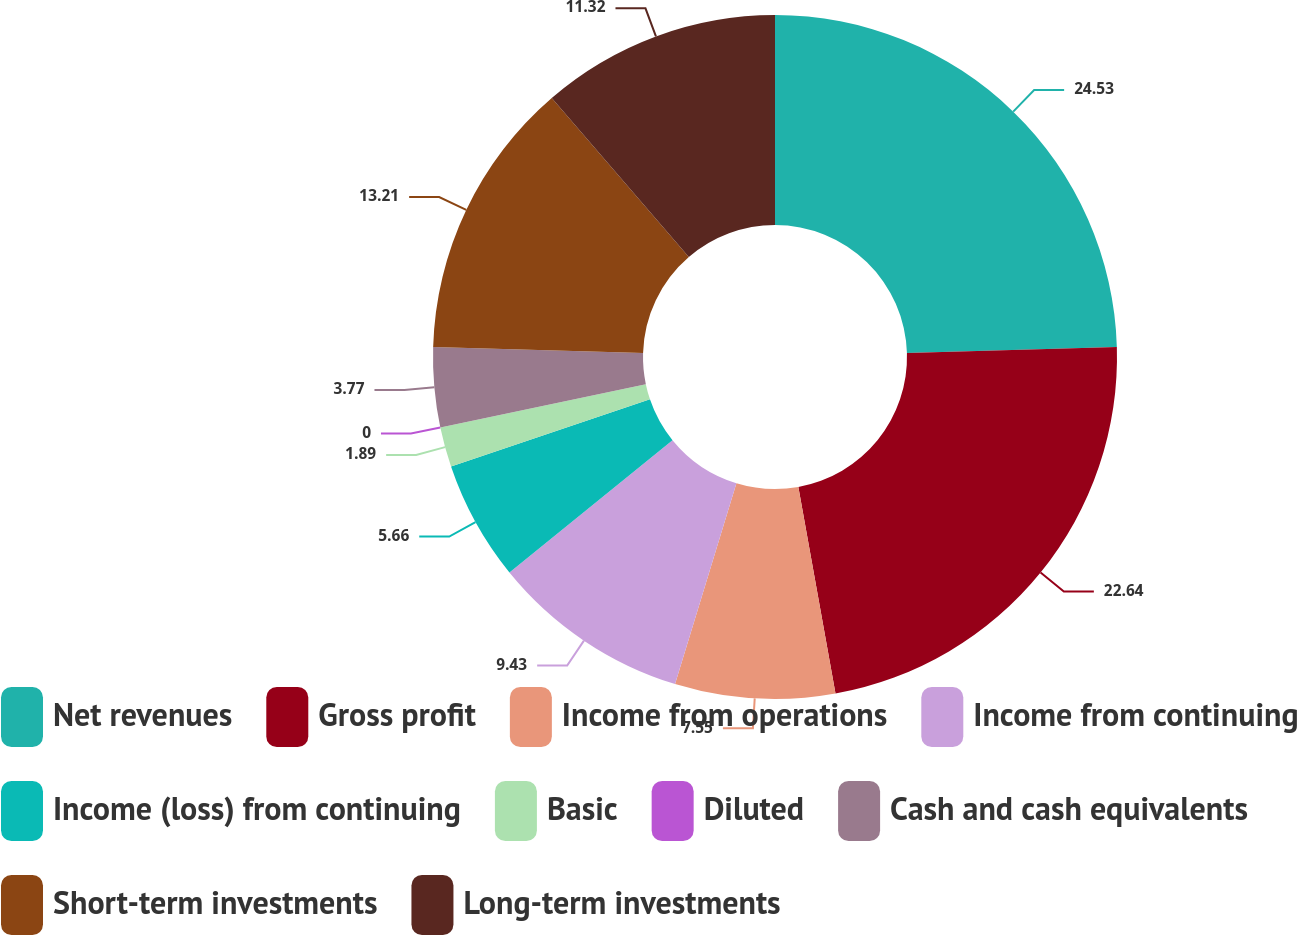<chart> <loc_0><loc_0><loc_500><loc_500><pie_chart><fcel>Net revenues<fcel>Gross profit<fcel>Income from operations<fcel>Income from continuing<fcel>Income (loss) from continuing<fcel>Basic<fcel>Diluted<fcel>Cash and cash equivalents<fcel>Short-term investments<fcel>Long-term investments<nl><fcel>24.53%<fcel>22.64%<fcel>7.55%<fcel>9.43%<fcel>5.66%<fcel>1.89%<fcel>0.0%<fcel>3.77%<fcel>13.21%<fcel>11.32%<nl></chart> 